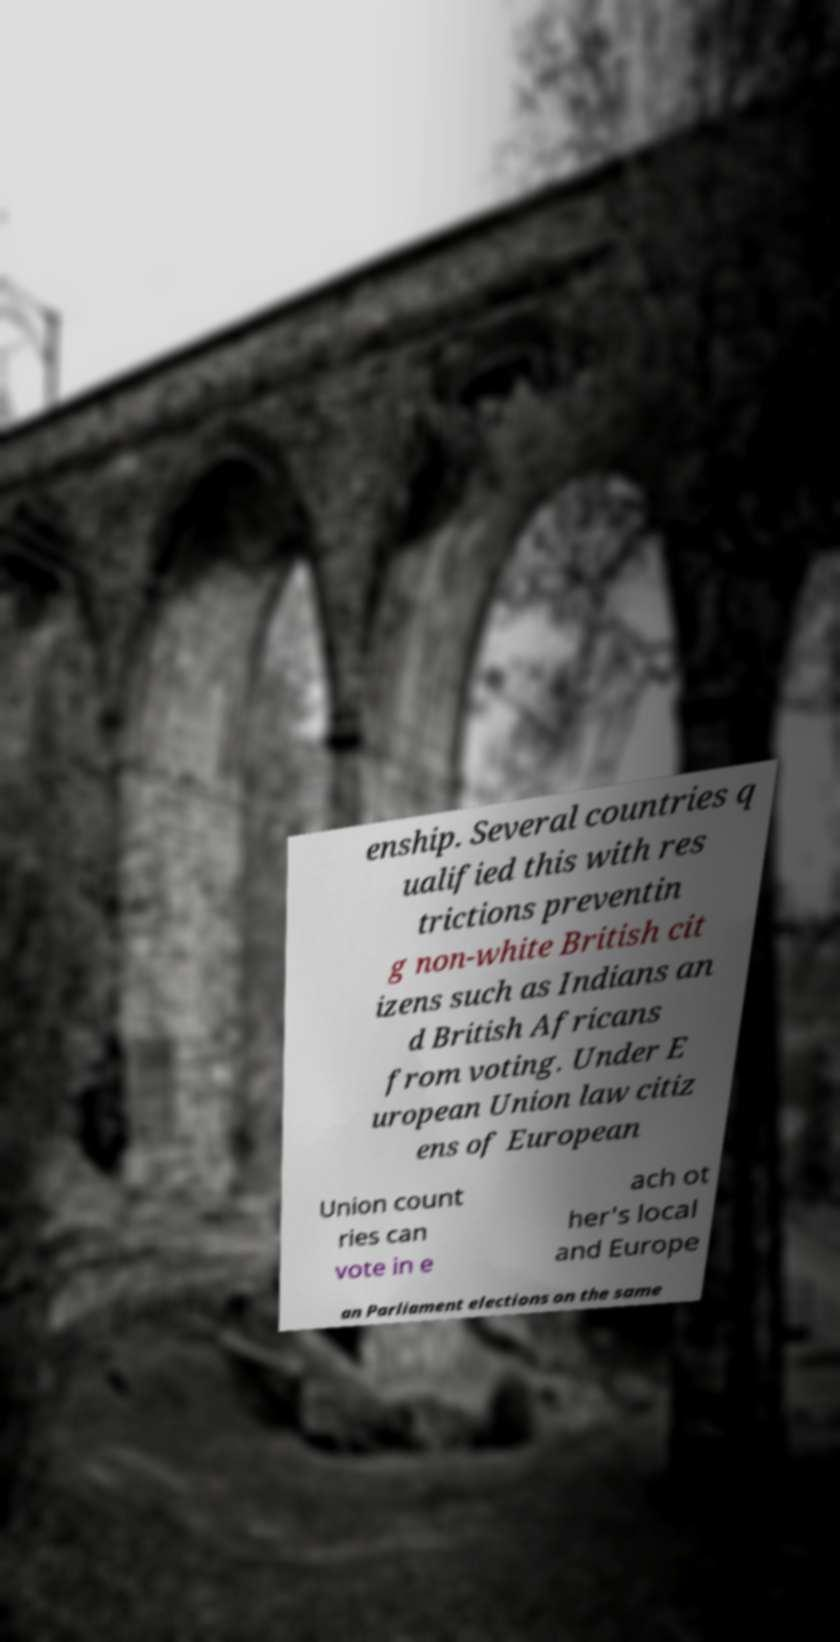There's text embedded in this image that I need extracted. Can you transcribe it verbatim? enship. Several countries q ualified this with res trictions preventin g non-white British cit izens such as Indians an d British Africans from voting. Under E uropean Union law citiz ens of European Union count ries can vote in e ach ot her's local and Europe an Parliament elections on the same 